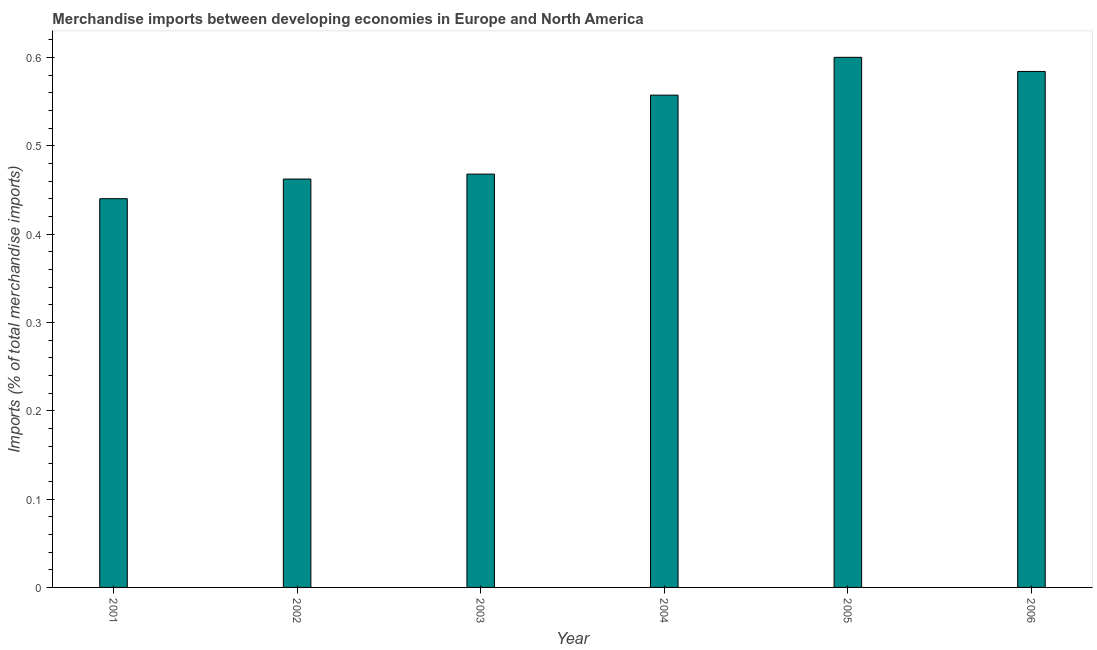Does the graph contain any zero values?
Keep it short and to the point. No. Does the graph contain grids?
Keep it short and to the point. No. What is the title of the graph?
Give a very brief answer. Merchandise imports between developing economies in Europe and North America. What is the label or title of the Y-axis?
Your answer should be very brief. Imports (% of total merchandise imports). What is the merchandise imports in 2006?
Your response must be concise. 0.58. Across all years, what is the maximum merchandise imports?
Your answer should be compact. 0.6. Across all years, what is the minimum merchandise imports?
Your response must be concise. 0.44. In which year was the merchandise imports maximum?
Offer a terse response. 2005. In which year was the merchandise imports minimum?
Your answer should be very brief. 2001. What is the sum of the merchandise imports?
Your response must be concise. 3.11. What is the difference between the merchandise imports in 2004 and 2006?
Your response must be concise. -0.03. What is the average merchandise imports per year?
Your response must be concise. 0.52. What is the median merchandise imports?
Your answer should be very brief. 0.51. In how many years, is the merchandise imports greater than 0.44 %?
Provide a succinct answer. 6. What is the ratio of the merchandise imports in 2004 to that in 2005?
Make the answer very short. 0.93. Is the merchandise imports in 2004 less than that in 2006?
Give a very brief answer. Yes. What is the difference between the highest and the second highest merchandise imports?
Ensure brevity in your answer.  0.02. Is the sum of the merchandise imports in 2003 and 2004 greater than the maximum merchandise imports across all years?
Provide a succinct answer. Yes. What is the difference between the highest and the lowest merchandise imports?
Your answer should be compact. 0.16. How many years are there in the graph?
Keep it short and to the point. 6. What is the Imports (% of total merchandise imports) in 2001?
Offer a very short reply. 0.44. What is the Imports (% of total merchandise imports) in 2002?
Ensure brevity in your answer.  0.46. What is the Imports (% of total merchandise imports) in 2003?
Make the answer very short. 0.47. What is the Imports (% of total merchandise imports) of 2004?
Make the answer very short. 0.56. What is the Imports (% of total merchandise imports) in 2005?
Offer a very short reply. 0.6. What is the Imports (% of total merchandise imports) in 2006?
Your response must be concise. 0.58. What is the difference between the Imports (% of total merchandise imports) in 2001 and 2002?
Your response must be concise. -0.02. What is the difference between the Imports (% of total merchandise imports) in 2001 and 2003?
Provide a succinct answer. -0.03. What is the difference between the Imports (% of total merchandise imports) in 2001 and 2004?
Give a very brief answer. -0.12. What is the difference between the Imports (% of total merchandise imports) in 2001 and 2005?
Keep it short and to the point. -0.16. What is the difference between the Imports (% of total merchandise imports) in 2001 and 2006?
Offer a terse response. -0.14. What is the difference between the Imports (% of total merchandise imports) in 2002 and 2003?
Make the answer very short. -0.01. What is the difference between the Imports (% of total merchandise imports) in 2002 and 2004?
Your response must be concise. -0.1. What is the difference between the Imports (% of total merchandise imports) in 2002 and 2005?
Offer a terse response. -0.14. What is the difference between the Imports (% of total merchandise imports) in 2002 and 2006?
Provide a short and direct response. -0.12. What is the difference between the Imports (% of total merchandise imports) in 2003 and 2004?
Ensure brevity in your answer.  -0.09. What is the difference between the Imports (% of total merchandise imports) in 2003 and 2005?
Your answer should be compact. -0.13. What is the difference between the Imports (% of total merchandise imports) in 2003 and 2006?
Make the answer very short. -0.12. What is the difference between the Imports (% of total merchandise imports) in 2004 and 2005?
Ensure brevity in your answer.  -0.04. What is the difference between the Imports (% of total merchandise imports) in 2004 and 2006?
Provide a short and direct response. -0.03. What is the difference between the Imports (% of total merchandise imports) in 2005 and 2006?
Your answer should be very brief. 0.02. What is the ratio of the Imports (% of total merchandise imports) in 2001 to that in 2003?
Your response must be concise. 0.94. What is the ratio of the Imports (% of total merchandise imports) in 2001 to that in 2004?
Ensure brevity in your answer.  0.79. What is the ratio of the Imports (% of total merchandise imports) in 2001 to that in 2005?
Ensure brevity in your answer.  0.73. What is the ratio of the Imports (% of total merchandise imports) in 2001 to that in 2006?
Ensure brevity in your answer.  0.75. What is the ratio of the Imports (% of total merchandise imports) in 2002 to that in 2003?
Offer a very short reply. 0.99. What is the ratio of the Imports (% of total merchandise imports) in 2002 to that in 2004?
Ensure brevity in your answer.  0.83. What is the ratio of the Imports (% of total merchandise imports) in 2002 to that in 2005?
Ensure brevity in your answer.  0.77. What is the ratio of the Imports (% of total merchandise imports) in 2002 to that in 2006?
Your response must be concise. 0.79. What is the ratio of the Imports (% of total merchandise imports) in 2003 to that in 2004?
Keep it short and to the point. 0.84. What is the ratio of the Imports (% of total merchandise imports) in 2003 to that in 2005?
Offer a terse response. 0.78. What is the ratio of the Imports (% of total merchandise imports) in 2003 to that in 2006?
Give a very brief answer. 0.8. What is the ratio of the Imports (% of total merchandise imports) in 2004 to that in 2005?
Give a very brief answer. 0.93. What is the ratio of the Imports (% of total merchandise imports) in 2004 to that in 2006?
Provide a succinct answer. 0.95. 